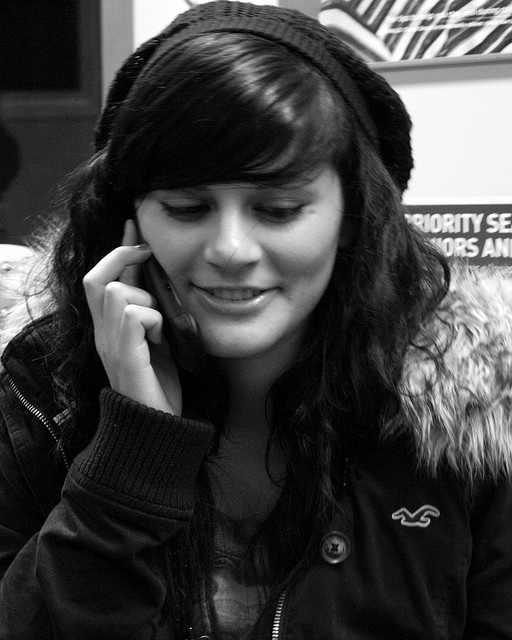Describe the objects in this image and their specific colors. I can see people in black, gray, darkgray, and lightgray tones and cell phone in black, gray, darkgray, and lightgray tones in this image. 